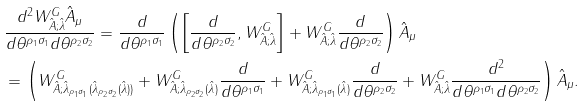<formula> <loc_0><loc_0><loc_500><loc_500>& \frac { d ^ { 2 } W ^ { G } _ { \hat { A } ; \hat { \lambda } } \hat { A } _ { \mu } } { d \theta ^ { \rho _ { 1 } \sigma _ { 1 } } d \theta ^ { \rho _ { 2 } \sigma _ { 2 } } } = \frac { d } { d \theta ^ { \rho _ { 1 } \sigma _ { 1 } } } \left ( \left [ \frac { d } { d \theta ^ { \rho _ { 2 } \sigma _ { 2 } } } , W ^ { G } _ { \hat { A } ; \hat { \lambda } } \right ] + W ^ { G } _ { \hat { A } ; \hat { \lambda } } \frac { d } { d \theta ^ { \rho _ { 2 } \sigma _ { 2 } } } \right ) \hat { A } _ { \mu } \\ & = \left ( W ^ { G } _ { \hat { A } ; \hat { \lambda } _ { \rho _ { 1 } \sigma _ { 1 } } ( \hat { \lambda } _ { \rho _ { 2 } \sigma _ { 2 } } ( \hat { \lambda } ) ) } + W ^ { G } _ { \hat { A } ; \hat { \lambda } _ { \rho _ { 2 } \sigma _ { 2 } } ( \hat { \lambda } ) } \frac { d } { d \theta ^ { \rho _ { 1 } \sigma _ { 1 } } } + W ^ { G } _ { \hat { A } ; \hat { \lambda } _ { \rho _ { 1 } \sigma _ { 1 } } ( \hat { \lambda } ) } \frac { d } { d \theta ^ { \rho _ { 2 } \sigma _ { 2 } } } + W ^ { G } _ { \hat { A } ; \hat { \lambda } } \frac { d ^ { 2 } } { d \theta ^ { \rho _ { 1 } \sigma _ { 1 } } d \theta ^ { \rho _ { 2 } \sigma _ { 2 } } } \right ) \hat { A } _ { \mu } .</formula> 